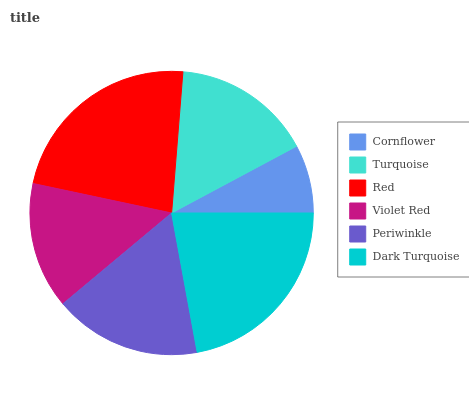Is Cornflower the minimum?
Answer yes or no. Yes. Is Red the maximum?
Answer yes or no. Yes. Is Turquoise the minimum?
Answer yes or no. No. Is Turquoise the maximum?
Answer yes or no. No. Is Turquoise greater than Cornflower?
Answer yes or no. Yes. Is Cornflower less than Turquoise?
Answer yes or no. Yes. Is Cornflower greater than Turquoise?
Answer yes or no. No. Is Turquoise less than Cornflower?
Answer yes or no. No. Is Periwinkle the high median?
Answer yes or no. Yes. Is Turquoise the low median?
Answer yes or no. Yes. Is Cornflower the high median?
Answer yes or no. No. Is Red the low median?
Answer yes or no. No. 